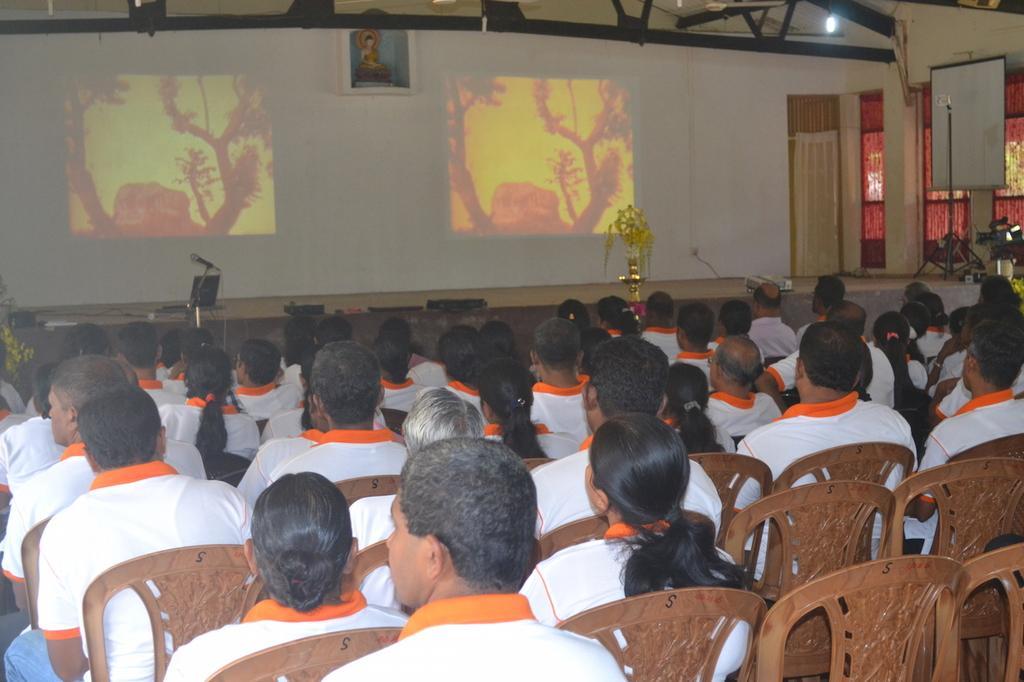Describe this image in one or two sentences. In the foreground of the picture there are people and chairs. In the center of the picture there is stage and there are mic, stand, light, projector screen, and other objects. In the background there are curtains, wall, frame and other objects. At the top there is an iron frame. 